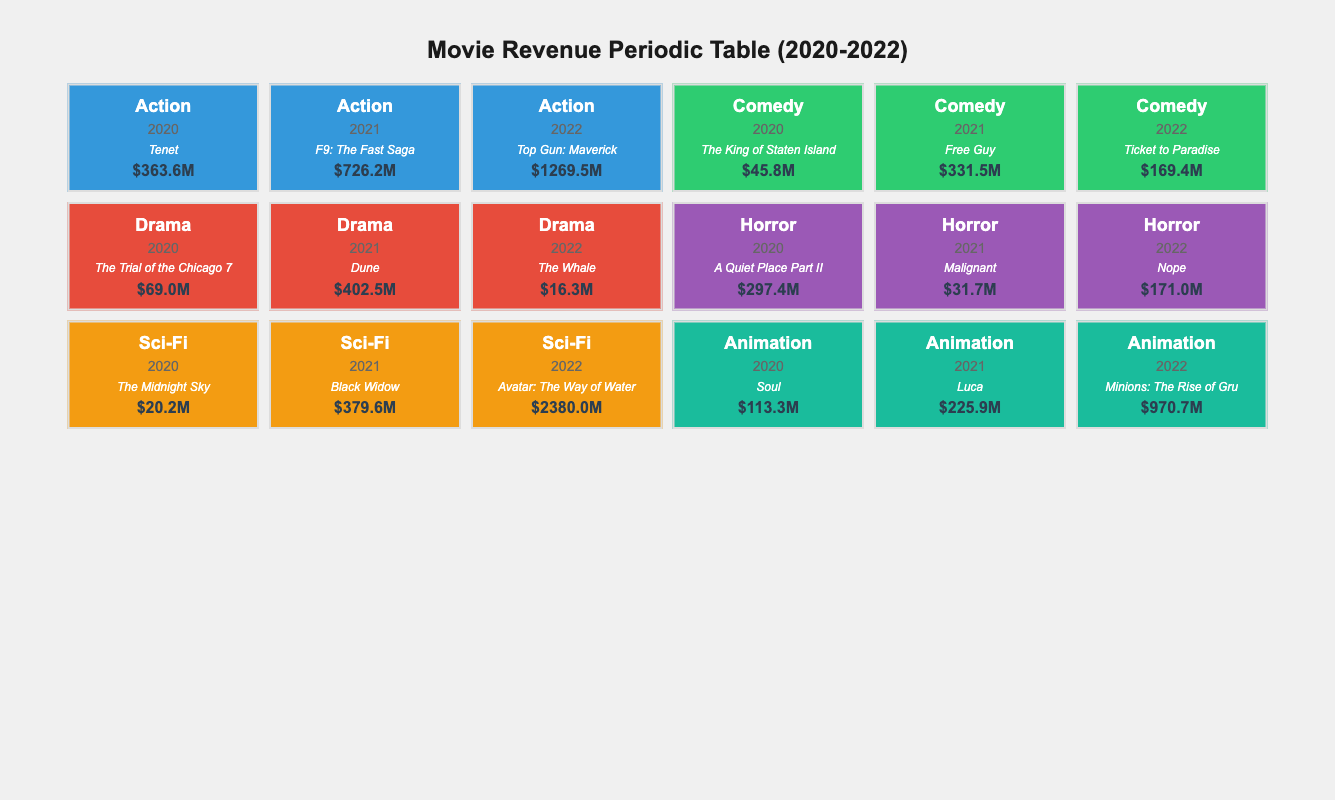What was the top-grossing action movie in 2022? The table lists "Top Gun: Maverick" as the top movie in the action genre for 2022 with a revenue of 1269.5 million USD.
Answer: Top Gun: Maverick Which genre had the highest revenue in 2022? In 2022, "Sci-Fi" had the highest revenue with "Avatar: The Way of Water," generating 2380 million USD, which is higher than any other genre.
Answer: Sci-Fi What is the revenue difference between the top comedy movie in 2021 and the top horror movie in 2021? The revenue of the top comedy movie "Free Guy" in 2021 is 331.5 million USD, while the top horror movie "Malignant" generated 31.7 million USD. The difference is calculated as 331.5 - 31.7 = 299.8 million USD.
Answer: 299.8 million USD Did the top-grossing drama movie in 2020 have a revenue higher than 100 million USD? The top drama movie in 2020 was "The Trial of the Chicago 7," which had a revenue of 69.0 million USD, which is less than 100 million USD, thus the answer is no.
Answer: No What was the average revenue of the animation genre across all three years? The revenues for the animation genre are 113.3 million USD (2020), 225.9 million USD (2021), and 970.7 million USD (2022). The sum is 113.3 + 225.9 + 970.7 = 1309.9 million USD. There are 3 years, so the average is 1309.9 / 3 = 436.63 million USD.
Answer: 436.63 million USD What was the total revenue for the horror genre across all three years? The revenues for the horror genre are 297.4 million USD (2020), 31.7 million USD (2021), and 171.0 million USD (2022). The total is calculated as 297.4 + 31.7 + 171.0 = 500.1 million USD.
Answer: 500.1 million USD Which year saw the largest increase in revenue for the action genre? The revenues for action are 363.6 million USD in 2020, 726.2 million USD in 2021, and 1269.5 million USD in 2022. The increases are 362.6 million USD from 2020 to 2021 and 543.3 million USD from 2021 to 2022. The largest increase was 543.3 million USD from 2021 to 2022.
Answer: 543.3 million USD Was there any year when the top movie in the horror genre generated more revenue than the top movie in the comedy genre? In 2020, "A Quiet Place Part II" (horror) made 297.4 million USD, while "The King of Staten Island" (comedy) earned 45.8 million USD, showing that horror did have a higher revenue. In 2021 and 2022, however, the horror movies did not surpass the revenues of the comedy films during those years. So the answer to the question is yes for 2020.
Answer: Yes In which year did the Sci-Fi genre achieve the highest revenue, and what was the total? The Sci-Fi genre earned revenues of 20.2 million USD in 2020, 379.6 million USD in 2021, and 2380 million USD in 2022. The highest revenue was in 2022 with 2380 million USD.
Answer: 2022, 2380 million USD 